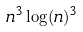Convert formula to latex. <formula><loc_0><loc_0><loc_500><loc_500>n ^ { 3 } \log ( n ) ^ { 3 }</formula> 